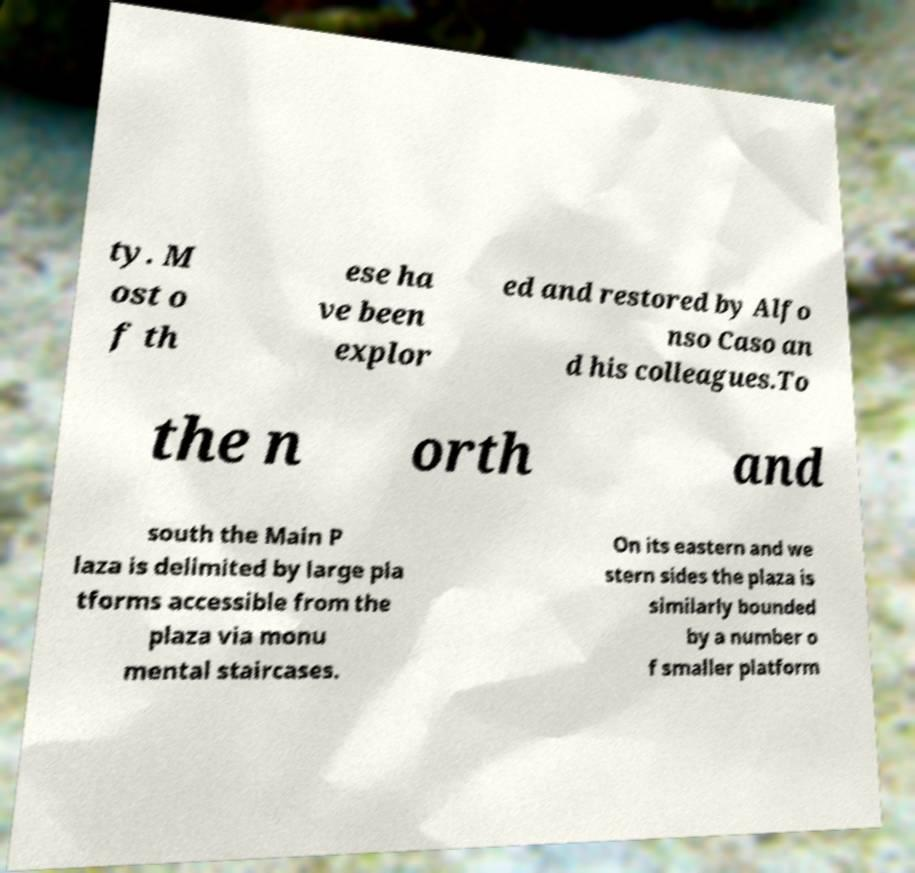There's text embedded in this image that I need extracted. Can you transcribe it verbatim? ty. M ost o f th ese ha ve been explor ed and restored by Alfo nso Caso an d his colleagues.To the n orth and south the Main P laza is delimited by large pla tforms accessible from the plaza via monu mental staircases. On its eastern and we stern sides the plaza is similarly bounded by a number o f smaller platform 